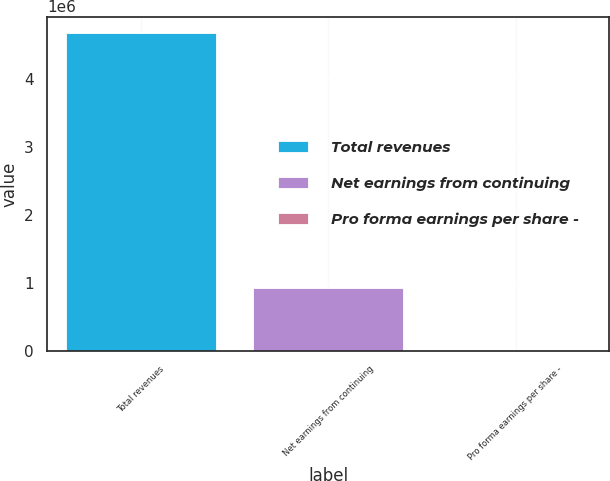<chart> <loc_0><loc_0><loc_500><loc_500><bar_chart><fcel>Total revenues<fcel>Net earnings from continuing<fcel>Pro forma earnings per share -<nl><fcel>4.68749e+06<fcel>937499<fcel>0.65<nl></chart> 